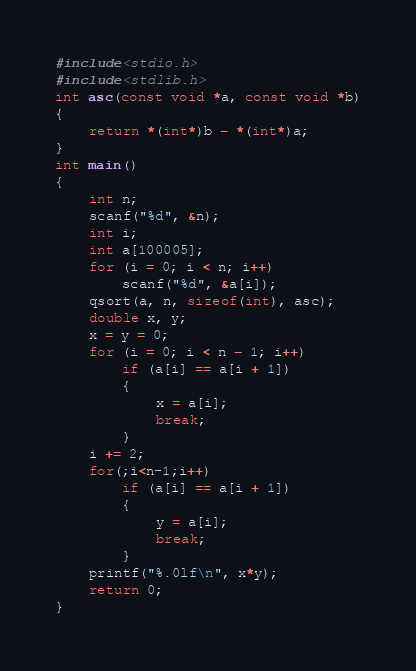<code> <loc_0><loc_0><loc_500><loc_500><_C_>#include<stdio.h>
#include<stdlib.h>
int asc(const void *a, const void *b)
{
    return *(int*)b - *(int*)a;
}
int main()
{
    int n;
    scanf("%d", &n);
    int i;
    int a[100005];
    for (i = 0; i < n; i++)
        scanf("%d", &a[i]);
    qsort(a, n, sizeof(int), asc);
    double x, y;
    x = y = 0;
    for (i = 0; i < n - 1; i++)
        if (a[i] == a[i + 1])
        {
            x = a[i];
            break;
        }
    i += 2;
    for(;i<n-1;i++)
        if (a[i] == a[i + 1])
        {
            y = a[i];
            break;
        }
    printf("%.0lf\n", x*y);
    return 0;
}</code> 